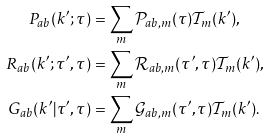Convert formula to latex. <formula><loc_0><loc_0><loc_500><loc_500>P _ { a b } ( k ^ { \prime } ; \tau ) & = \sum _ { m } \mathcal { P } _ { a b , m } ( \tau ) \mathcal { T } _ { m } ( k ^ { \prime } ) , \\ R _ { a b } ( k ^ { \prime } ; \tau ^ { \prime } , \tau ) & = \sum _ { m } \mathcal { R } _ { a b , m } ( \tau ^ { \prime } , \tau ) \mathcal { T } _ { m } ( k ^ { \prime } ) , \\ G _ { a b } ( k ^ { \prime } | \tau ^ { \prime } , \tau ) & = \sum _ { m } \mathcal { G } _ { a b , m } ( \tau ^ { \prime } , \tau ) \mathcal { T } _ { m } ( k ^ { \prime } ) .</formula> 